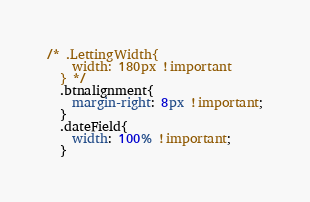Convert code to text. <code><loc_0><loc_0><loc_500><loc_500><_CSS_>/* .LettingWidth{
    width: 180px !important
  } */
  .btnalignment{
    margin-right: 8px !important;
  }
  .dateField{
    width: 100% !important;
  }</code> 